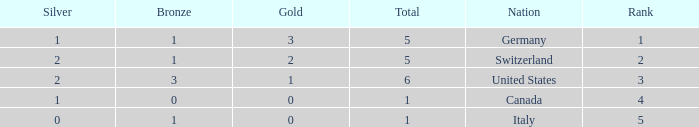How many golds for nations with over 0 silvers, over 1 total, and over 3 bronze? 0.0. 